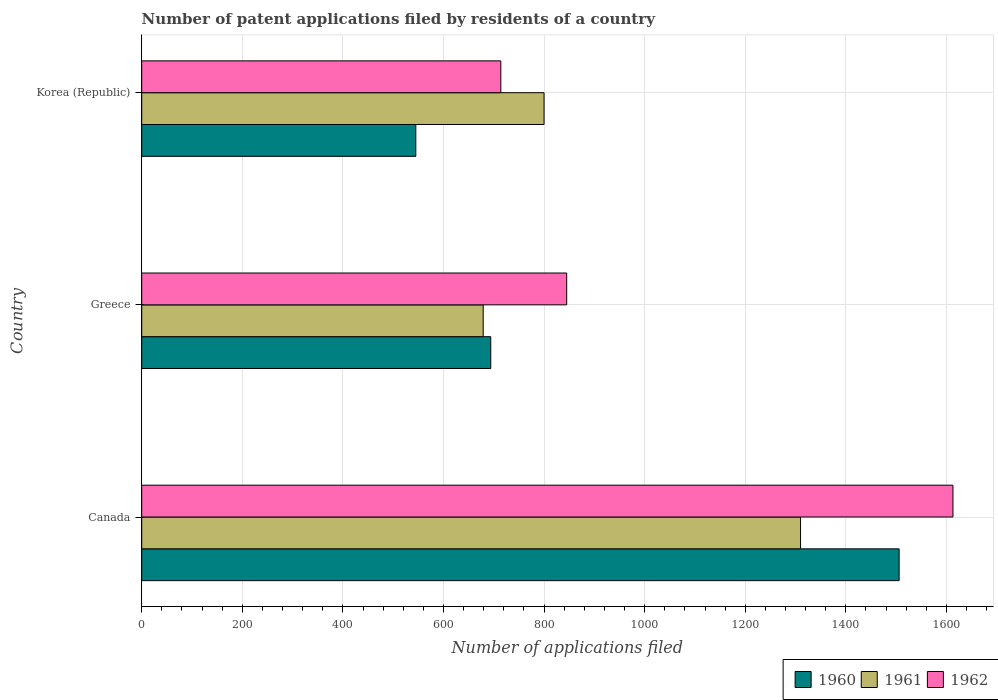How many groups of bars are there?
Provide a succinct answer. 3. Are the number of bars on each tick of the Y-axis equal?
Your answer should be compact. Yes. How many bars are there on the 2nd tick from the top?
Ensure brevity in your answer.  3. How many bars are there on the 2nd tick from the bottom?
Your answer should be compact. 3. In how many cases, is the number of bars for a given country not equal to the number of legend labels?
Give a very brief answer. 0. What is the number of applications filed in 1961 in Canada?
Your answer should be compact. 1310. Across all countries, what is the maximum number of applications filed in 1960?
Keep it short and to the point. 1506. Across all countries, what is the minimum number of applications filed in 1961?
Offer a terse response. 679. In which country was the number of applications filed in 1961 maximum?
Offer a terse response. Canada. In which country was the number of applications filed in 1961 minimum?
Keep it short and to the point. Greece. What is the total number of applications filed in 1961 in the graph?
Ensure brevity in your answer.  2789. What is the difference between the number of applications filed in 1962 in Canada and that in Korea (Republic)?
Provide a succinct answer. 899. What is the average number of applications filed in 1962 per country?
Offer a terse response. 1057.33. What is the difference between the number of applications filed in 1962 and number of applications filed in 1961 in Canada?
Offer a terse response. 303. In how many countries, is the number of applications filed in 1961 greater than 560 ?
Make the answer very short. 3. What is the ratio of the number of applications filed in 1962 in Canada to that in Korea (Republic)?
Your answer should be very brief. 2.26. Is the difference between the number of applications filed in 1962 in Greece and Korea (Republic) greater than the difference between the number of applications filed in 1961 in Greece and Korea (Republic)?
Your answer should be compact. Yes. What is the difference between the highest and the second highest number of applications filed in 1961?
Keep it short and to the point. 510. What is the difference between the highest and the lowest number of applications filed in 1960?
Provide a short and direct response. 961. In how many countries, is the number of applications filed in 1962 greater than the average number of applications filed in 1962 taken over all countries?
Your answer should be very brief. 1. Is the sum of the number of applications filed in 1960 in Canada and Korea (Republic) greater than the maximum number of applications filed in 1961 across all countries?
Keep it short and to the point. Yes. Is it the case that in every country, the sum of the number of applications filed in 1962 and number of applications filed in 1961 is greater than the number of applications filed in 1960?
Provide a short and direct response. Yes. How many countries are there in the graph?
Offer a very short reply. 3. What is the difference between two consecutive major ticks on the X-axis?
Provide a short and direct response. 200. Does the graph contain grids?
Make the answer very short. Yes. How many legend labels are there?
Your response must be concise. 3. What is the title of the graph?
Offer a terse response. Number of patent applications filed by residents of a country. What is the label or title of the X-axis?
Keep it short and to the point. Number of applications filed. What is the label or title of the Y-axis?
Offer a very short reply. Country. What is the Number of applications filed in 1960 in Canada?
Your answer should be very brief. 1506. What is the Number of applications filed of 1961 in Canada?
Your response must be concise. 1310. What is the Number of applications filed in 1962 in Canada?
Keep it short and to the point. 1613. What is the Number of applications filed of 1960 in Greece?
Give a very brief answer. 694. What is the Number of applications filed in 1961 in Greece?
Offer a terse response. 679. What is the Number of applications filed of 1962 in Greece?
Give a very brief answer. 845. What is the Number of applications filed of 1960 in Korea (Republic)?
Your response must be concise. 545. What is the Number of applications filed in 1961 in Korea (Republic)?
Your answer should be compact. 800. What is the Number of applications filed in 1962 in Korea (Republic)?
Offer a very short reply. 714. Across all countries, what is the maximum Number of applications filed in 1960?
Offer a very short reply. 1506. Across all countries, what is the maximum Number of applications filed of 1961?
Provide a short and direct response. 1310. Across all countries, what is the maximum Number of applications filed in 1962?
Ensure brevity in your answer.  1613. Across all countries, what is the minimum Number of applications filed in 1960?
Provide a succinct answer. 545. Across all countries, what is the minimum Number of applications filed in 1961?
Offer a terse response. 679. Across all countries, what is the minimum Number of applications filed of 1962?
Ensure brevity in your answer.  714. What is the total Number of applications filed in 1960 in the graph?
Offer a very short reply. 2745. What is the total Number of applications filed of 1961 in the graph?
Offer a terse response. 2789. What is the total Number of applications filed in 1962 in the graph?
Your response must be concise. 3172. What is the difference between the Number of applications filed in 1960 in Canada and that in Greece?
Give a very brief answer. 812. What is the difference between the Number of applications filed in 1961 in Canada and that in Greece?
Keep it short and to the point. 631. What is the difference between the Number of applications filed in 1962 in Canada and that in Greece?
Make the answer very short. 768. What is the difference between the Number of applications filed in 1960 in Canada and that in Korea (Republic)?
Your response must be concise. 961. What is the difference between the Number of applications filed in 1961 in Canada and that in Korea (Republic)?
Your answer should be compact. 510. What is the difference between the Number of applications filed of 1962 in Canada and that in Korea (Republic)?
Make the answer very short. 899. What is the difference between the Number of applications filed of 1960 in Greece and that in Korea (Republic)?
Ensure brevity in your answer.  149. What is the difference between the Number of applications filed in 1961 in Greece and that in Korea (Republic)?
Make the answer very short. -121. What is the difference between the Number of applications filed of 1962 in Greece and that in Korea (Republic)?
Keep it short and to the point. 131. What is the difference between the Number of applications filed in 1960 in Canada and the Number of applications filed in 1961 in Greece?
Your answer should be compact. 827. What is the difference between the Number of applications filed in 1960 in Canada and the Number of applications filed in 1962 in Greece?
Offer a very short reply. 661. What is the difference between the Number of applications filed of 1961 in Canada and the Number of applications filed of 1962 in Greece?
Ensure brevity in your answer.  465. What is the difference between the Number of applications filed of 1960 in Canada and the Number of applications filed of 1961 in Korea (Republic)?
Make the answer very short. 706. What is the difference between the Number of applications filed in 1960 in Canada and the Number of applications filed in 1962 in Korea (Republic)?
Your answer should be very brief. 792. What is the difference between the Number of applications filed of 1961 in Canada and the Number of applications filed of 1962 in Korea (Republic)?
Provide a short and direct response. 596. What is the difference between the Number of applications filed in 1960 in Greece and the Number of applications filed in 1961 in Korea (Republic)?
Keep it short and to the point. -106. What is the difference between the Number of applications filed of 1961 in Greece and the Number of applications filed of 1962 in Korea (Republic)?
Ensure brevity in your answer.  -35. What is the average Number of applications filed of 1960 per country?
Your answer should be very brief. 915. What is the average Number of applications filed in 1961 per country?
Keep it short and to the point. 929.67. What is the average Number of applications filed in 1962 per country?
Your answer should be compact. 1057.33. What is the difference between the Number of applications filed of 1960 and Number of applications filed of 1961 in Canada?
Make the answer very short. 196. What is the difference between the Number of applications filed in 1960 and Number of applications filed in 1962 in Canada?
Give a very brief answer. -107. What is the difference between the Number of applications filed of 1961 and Number of applications filed of 1962 in Canada?
Give a very brief answer. -303. What is the difference between the Number of applications filed in 1960 and Number of applications filed in 1962 in Greece?
Offer a very short reply. -151. What is the difference between the Number of applications filed in 1961 and Number of applications filed in 1962 in Greece?
Give a very brief answer. -166. What is the difference between the Number of applications filed of 1960 and Number of applications filed of 1961 in Korea (Republic)?
Your response must be concise. -255. What is the difference between the Number of applications filed of 1960 and Number of applications filed of 1962 in Korea (Republic)?
Your response must be concise. -169. What is the ratio of the Number of applications filed of 1960 in Canada to that in Greece?
Keep it short and to the point. 2.17. What is the ratio of the Number of applications filed in 1961 in Canada to that in Greece?
Give a very brief answer. 1.93. What is the ratio of the Number of applications filed in 1962 in Canada to that in Greece?
Your answer should be compact. 1.91. What is the ratio of the Number of applications filed of 1960 in Canada to that in Korea (Republic)?
Ensure brevity in your answer.  2.76. What is the ratio of the Number of applications filed of 1961 in Canada to that in Korea (Republic)?
Your response must be concise. 1.64. What is the ratio of the Number of applications filed of 1962 in Canada to that in Korea (Republic)?
Your answer should be compact. 2.26. What is the ratio of the Number of applications filed in 1960 in Greece to that in Korea (Republic)?
Your answer should be compact. 1.27. What is the ratio of the Number of applications filed of 1961 in Greece to that in Korea (Republic)?
Provide a short and direct response. 0.85. What is the ratio of the Number of applications filed of 1962 in Greece to that in Korea (Republic)?
Provide a short and direct response. 1.18. What is the difference between the highest and the second highest Number of applications filed in 1960?
Offer a very short reply. 812. What is the difference between the highest and the second highest Number of applications filed of 1961?
Provide a succinct answer. 510. What is the difference between the highest and the second highest Number of applications filed in 1962?
Your response must be concise. 768. What is the difference between the highest and the lowest Number of applications filed of 1960?
Ensure brevity in your answer.  961. What is the difference between the highest and the lowest Number of applications filed of 1961?
Offer a very short reply. 631. What is the difference between the highest and the lowest Number of applications filed of 1962?
Provide a succinct answer. 899. 